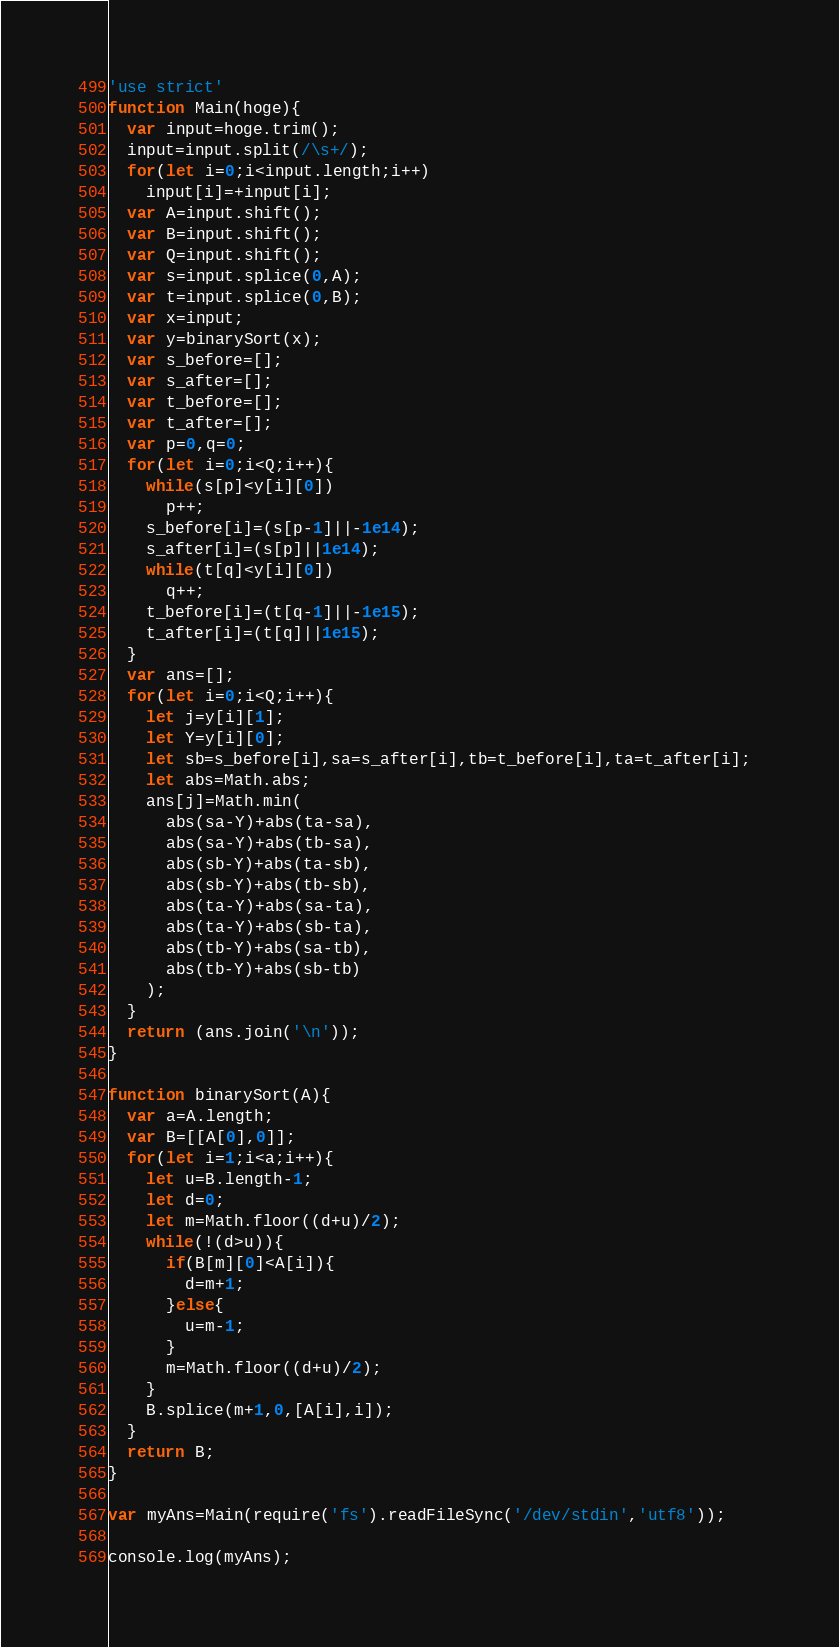Convert code to text. <code><loc_0><loc_0><loc_500><loc_500><_JavaScript_>'use strict'
function Main(hoge){
  var input=hoge.trim();
  input=input.split(/\s+/);
  for(let i=0;i<input.length;i++)
    input[i]=+input[i];
  var A=input.shift();
  var B=input.shift();
  var Q=input.shift();
  var s=input.splice(0,A);
  var t=input.splice(0,B);
  var x=input;
  var y=binarySort(x);
  var s_before=[];
  var s_after=[];
  var t_before=[];
  var t_after=[];
  var p=0,q=0;
  for(let i=0;i<Q;i++){
    while(s[p]<y[i][0])
      p++;
    s_before[i]=(s[p-1]||-1e14);
    s_after[i]=(s[p]||1e14);
    while(t[q]<y[i][0])
      q++;
    t_before[i]=(t[q-1]||-1e15);
    t_after[i]=(t[q]||1e15);
  }
  var ans=[];
  for(let i=0;i<Q;i++){
    let j=y[i][1];
    let Y=y[i][0];
    let sb=s_before[i],sa=s_after[i],tb=t_before[i],ta=t_after[i]; 
    let abs=Math.abs;
    ans[j]=Math.min(
      abs(sa-Y)+abs(ta-sa),
      abs(sa-Y)+abs(tb-sa),
      abs(sb-Y)+abs(ta-sb),
      abs(sb-Y)+abs(tb-sb),
      abs(ta-Y)+abs(sa-ta),
      abs(ta-Y)+abs(sb-ta),
      abs(tb-Y)+abs(sa-tb),
      abs(tb-Y)+abs(sb-tb)
    );
  }
  return (ans.join('\n'));
}

function binarySort(A){ 
  var a=A.length;
  var B=[[A[0],0]];
  for(let i=1;i<a;i++){
    let u=B.length-1;
    let d=0;
    let m=Math.floor((d+u)/2);
    while(!(d>u)){
      if(B[m][0]<A[i]){
        d=m+1;
      }else{
        u=m-1;
      }
      m=Math.floor((d+u)/2);
    }
    B.splice(m+1,0,[A[i],i]);
  }
  return B;
}

var myAns=Main(require('fs').readFileSync('/dev/stdin','utf8'));

console.log(myAns);
</code> 